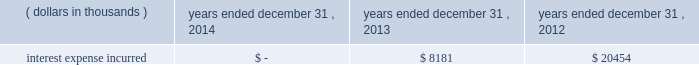Junior subordinated debt securities payable in accordance with the provisions of the junior subordinated debt securities which were issued on march 29 , 2004 , holdings elected to redeem the $ 329897 thousand of 6.2% ( 6.2 % ) junior subordinated debt securities outstanding on may 24 , 2013 .
As a result of the early redemption , the company incurred pre-tax expense of $ 7282 thousand related to the immediate amortization of the remaining capitalized issuance costs on the trust preferred securities .
Interest expense incurred in connection with these junior subordinated debt securities is as follows for the periods indicated: .
Holdings considered the mechanisms and obligations relating to the trust preferred securities , taken together , constituted a full and unconditional guarantee by holdings of capital trust ii 2019s payment obligations with respect to their trust preferred securities .
10 .
Reinsurance and trust agreements certain subsidiaries of group have established trust agreements , which effectively use the company 2019s investments as collateral , as security for assumed losses payable to certain non-affiliated ceding companies .
At december 31 , 2014 , the total amount on deposit in trust accounts was $ 322285 thousand .
On april 24 , 2014 , the company entered into two collateralized reinsurance agreements with kilimanjaro re limited ( 201ckilimanjaro 201d ) , a bermuda based special purpose reinsurer , to provide the company with catastrophe reinsurance coverage .
These agreements are multi-year reinsurance contracts which cover specified named storm and earthquake events .
The first agreement provides up to $ 250000 thousand of reinsurance coverage from named storms in specified states of the southeastern united states .
The second agreement provides up to $ 200000 thousand of reinsurance coverage from named storms in specified states of the southeast , mid-atlantic and northeast regions of the united states and puerto rico as well as reinsurance coverage from earthquakes in specified states of the southeast , mid-atlantic , northeast and west regions of the united states , puerto rico and british columbia .
On november 18 , 2014 , the company entered into a collateralized reinsurance agreement with kilimanjaro re to provide the company with catastrophe reinsurance coverage .
This agreement is a multi-year reinsurance contract which covers specified earthquake events .
The agreement provides up to $ 500000 thousand of reinsurance coverage from earthquakes in the united states , puerto rico and canada .
Kilimanjaro has financed the various property catastrophe reinsurance coverage by issuing catastrophe bonds to unrelated , external investors .
On april 24 , 2014 , kilimanjaro issued $ 450000 thousand of variable rate notes ( 201cseries 2014-1 notes 201d ) .
On november 18 , 2014 , kilimanjaro issued $ 500000 thousand of variable rate notes ( 201cseries 2014-2 notes 201d ) .
The proceeds from the issuance of the series 2014-1 notes and the series 2014-2 notes are held in reinsurance trust throughout the duration of the applicable reinsurance agreements and invested solely in us government money market funds with a rating of at least 201caaam 201d by standard & poor 2019s. .
What is the percentage change in interest expense from 2012 to 2013? 
Computations: ((8181 - 20454) / 20454)
Answer: -0.60003. Junior subordinated debt securities payable in accordance with the provisions of the junior subordinated debt securities which were issued on march 29 , 2004 , holdings elected to redeem the $ 329897 thousand of 6.2% ( 6.2 % ) junior subordinated debt securities outstanding on may 24 , 2013 .
As a result of the early redemption , the company incurred pre-tax expense of $ 7282 thousand related to the immediate amortization of the remaining capitalized issuance costs on the trust preferred securities .
Interest expense incurred in connection with these junior subordinated debt securities is as follows for the periods indicated: .
Holdings considered the mechanisms and obligations relating to the trust preferred securities , taken together , constituted a full and unconditional guarantee by holdings of capital trust ii 2019s payment obligations with respect to their trust preferred securities .
10 .
Reinsurance and trust agreements certain subsidiaries of group have established trust agreements , which effectively use the company 2019s investments as collateral , as security for assumed losses payable to certain non-affiliated ceding companies .
At december 31 , 2014 , the total amount on deposit in trust accounts was $ 322285 thousand .
On april 24 , 2014 , the company entered into two collateralized reinsurance agreements with kilimanjaro re limited ( 201ckilimanjaro 201d ) , a bermuda based special purpose reinsurer , to provide the company with catastrophe reinsurance coverage .
These agreements are multi-year reinsurance contracts which cover specified named storm and earthquake events .
The first agreement provides up to $ 250000 thousand of reinsurance coverage from named storms in specified states of the southeastern united states .
The second agreement provides up to $ 200000 thousand of reinsurance coverage from named storms in specified states of the southeast , mid-atlantic and northeast regions of the united states and puerto rico as well as reinsurance coverage from earthquakes in specified states of the southeast , mid-atlantic , northeast and west regions of the united states , puerto rico and british columbia .
On november 18 , 2014 , the company entered into a collateralized reinsurance agreement with kilimanjaro re to provide the company with catastrophe reinsurance coverage .
This agreement is a multi-year reinsurance contract which covers specified earthquake events .
The agreement provides up to $ 500000 thousand of reinsurance coverage from earthquakes in the united states , puerto rico and canada .
Kilimanjaro has financed the various property catastrophe reinsurance coverage by issuing catastrophe bonds to unrelated , external investors .
On april 24 , 2014 , kilimanjaro issued $ 450000 thousand of variable rate notes ( 201cseries 2014-1 notes 201d ) .
On november 18 , 2014 , kilimanjaro issued $ 500000 thousand of variable rate notes ( 201cseries 2014-2 notes 201d ) .
The proceeds from the issuance of the series 2014-1 notes and the series 2014-2 notes are held in reinsurance trust throughout the duration of the applicable reinsurance agreements and invested solely in us government money market funds with a rating of at least 201caaam 201d by standard & poor 2019s. .
What is the total amount of notes issued by kilimanjaro in 2014 , in thousands? 
Computations: (450000 + 500000)
Answer: 950000.0. 